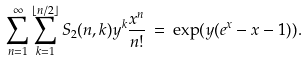<formula> <loc_0><loc_0><loc_500><loc_500>\sum _ { n = 1 } ^ { \infty } \sum _ { k = 1 } ^ { \lfloor n / 2 \rfloor } S _ { 2 } ( n , k ) y ^ { k } \frac { x ^ { n } } { n ! } \, = \, \exp ( y ( e ^ { x } - x - 1 ) ) .</formula> 